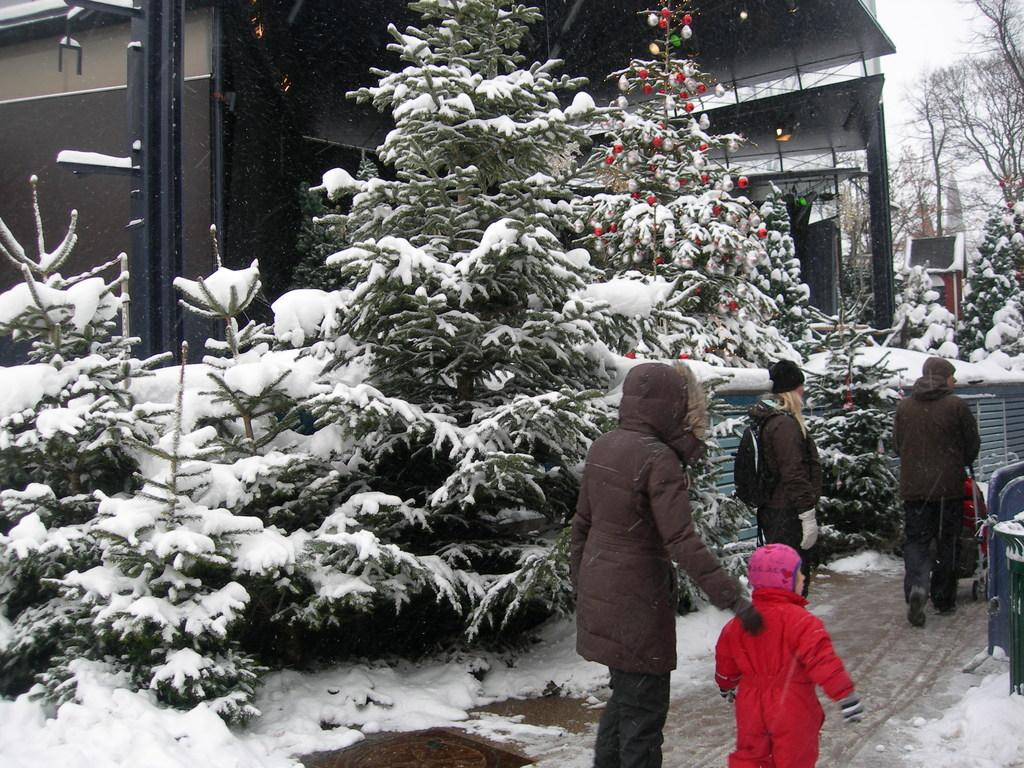How many persons are in the image? There are persons in the image. What are the persons wearing? The persons are wearing sweaters. What are the persons doing in the image? The persons are walking on a road. What is a festive element present in the image? There are Christmas trees in the image. What type of building can be seen in the image? There is a house in the image. What is the weather like in the image? There is snow visible in the image, indicating a cold and likely wintery weather. What type of vegetation is present in the image? There are trees in the image. What type of cough medicine is visible in the image? There is no cough medicine present in the image. What type of breakfast is being prepared in the image? There is no breakfast preparation visible in the image. 